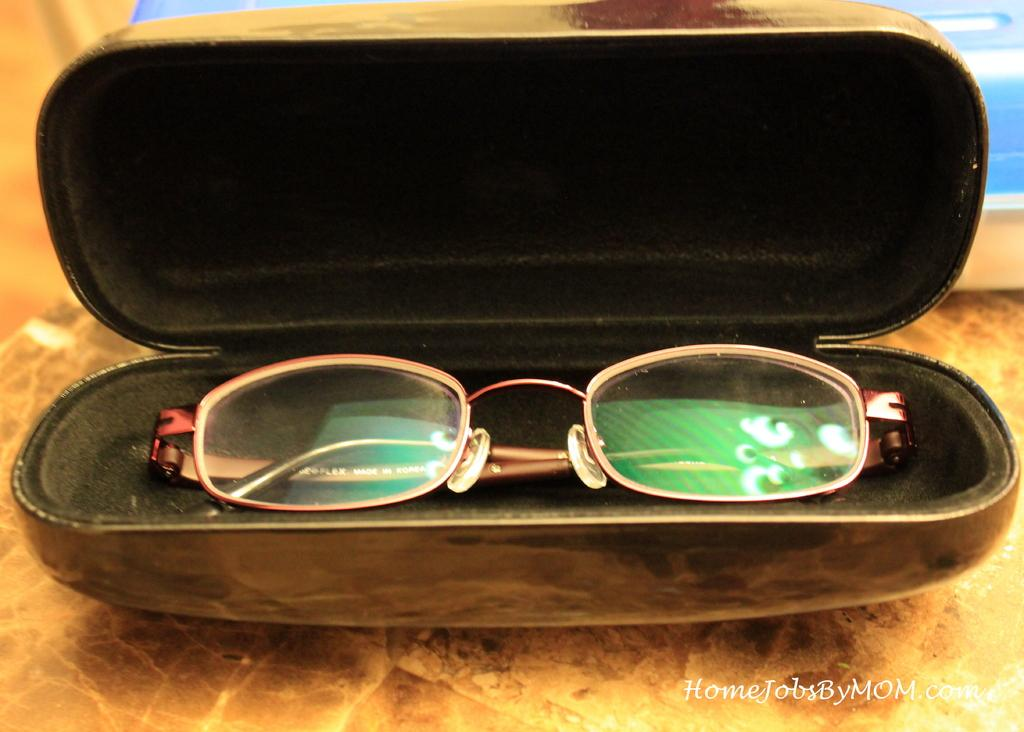What object is present in the image? There are spectacles in the image. Where are the spectacles stored? The spectacles are kept in a spectacle box. What type of sidewalk is visible in the image? There is no sidewalk present in the image; it only features spectacles and a spectacle box. 